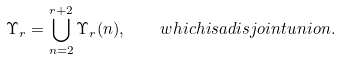Convert formula to latex. <formula><loc_0><loc_0><loc_500><loc_500>\Upsilon _ { r } = \bigcup _ { n = 2 } ^ { r + 2 } \Upsilon _ { r } ( n ) , \quad w h i c h i s a d i s j o i n t u n i o n .</formula> 